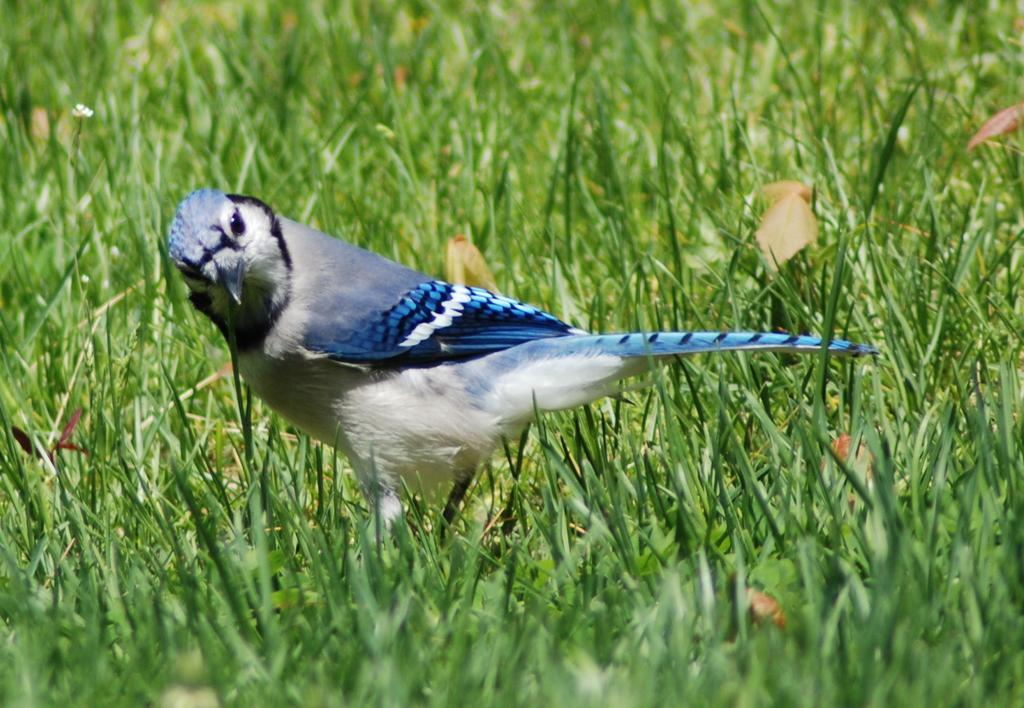What type of animal can be seen in the image? There is a bird in the image. Where is the bird located in the image? The bird is standing on the ground. What type of vegetation is present on the ground in the image? There is grass on the ground in the image. What type of crime is the judge discussing with the bird in the image? There is no judge or crime present in the image; it features a bird standing on the ground with grass. What topic are the bird and the judge talking about in the image? There is no judge or conversation present in the image, as it only shows a bird standing on the ground with grass. 